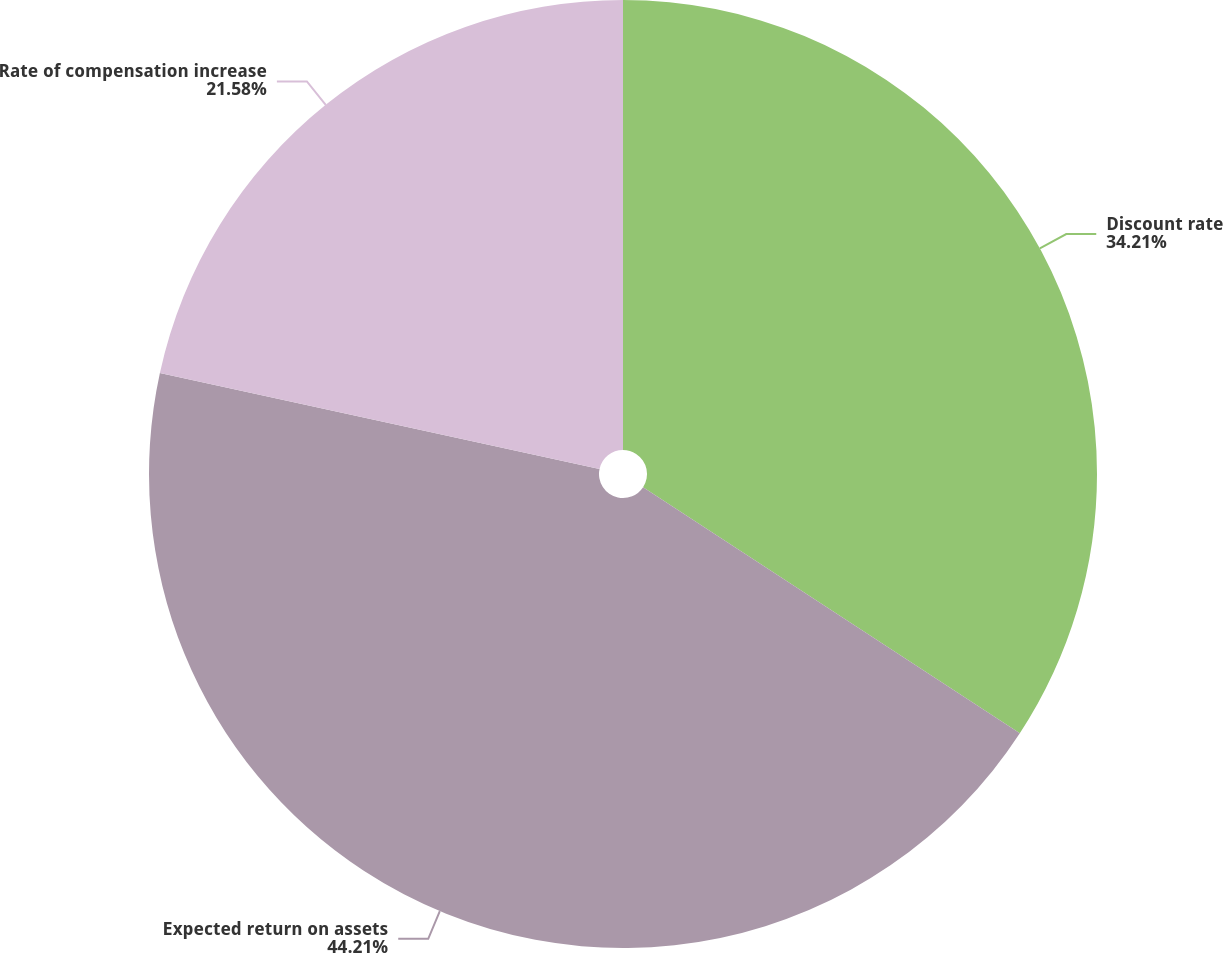Convert chart. <chart><loc_0><loc_0><loc_500><loc_500><pie_chart><fcel>Discount rate<fcel>Expected return on assets<fcel>Rate of compensation increase<nl><fcel>34.21%<fcel>44.21%<fcel>21.58%<nl></chart> 